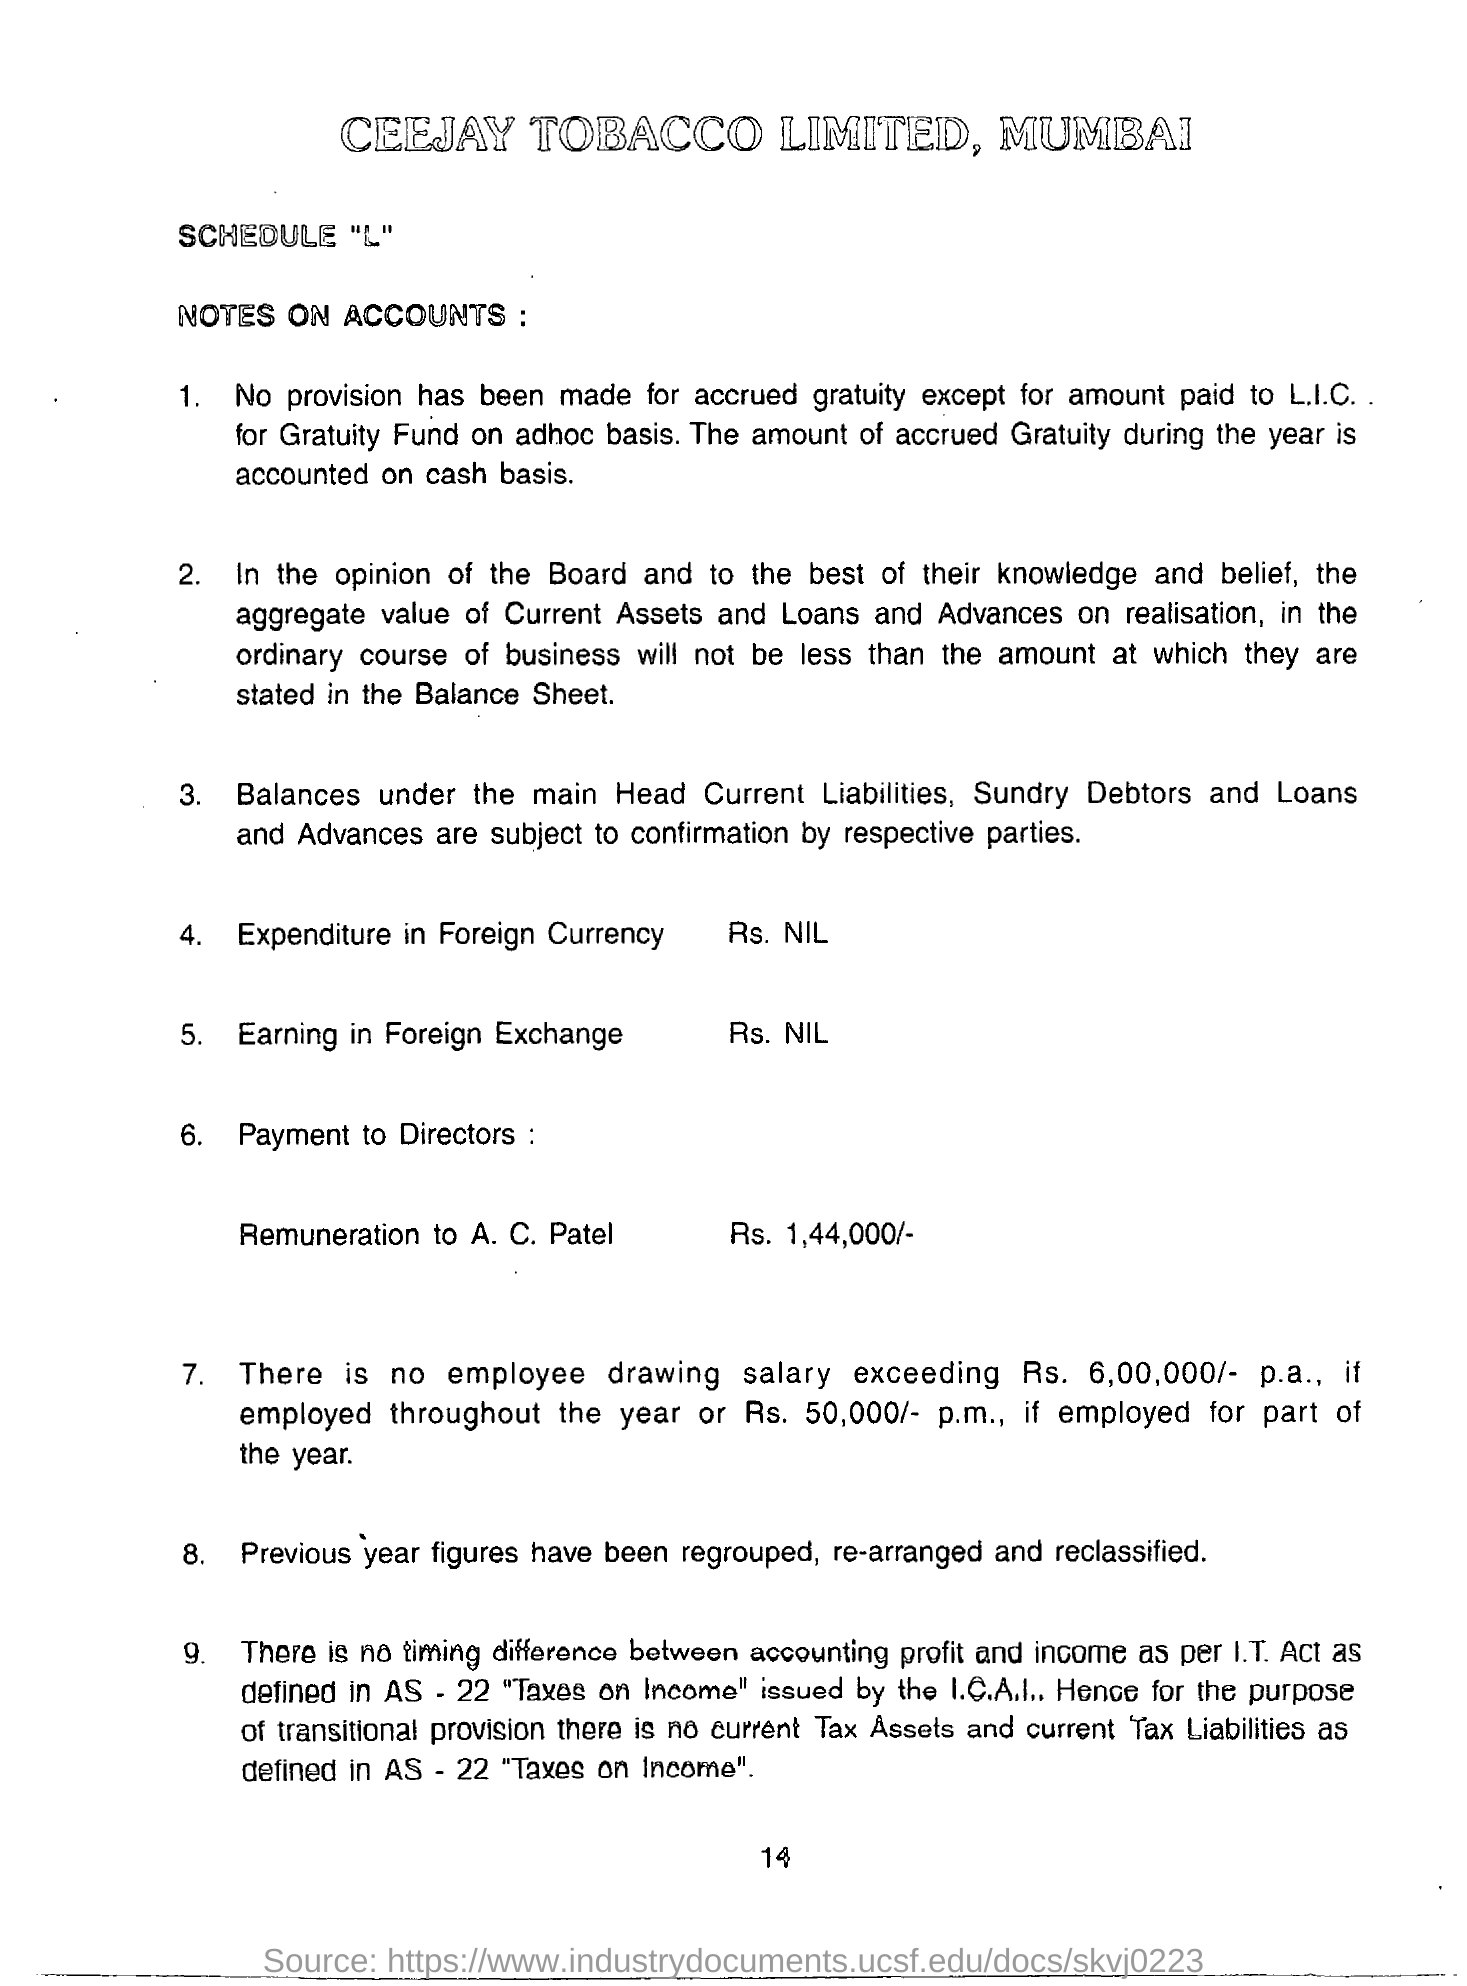Outline some significant characteristics in this image. The location of MUMBAI is located. CEEJAY TOBACCO LIMITED is the name of a company. A. C. Patel was given a remuneration of Rs. 1,44,000/-. 